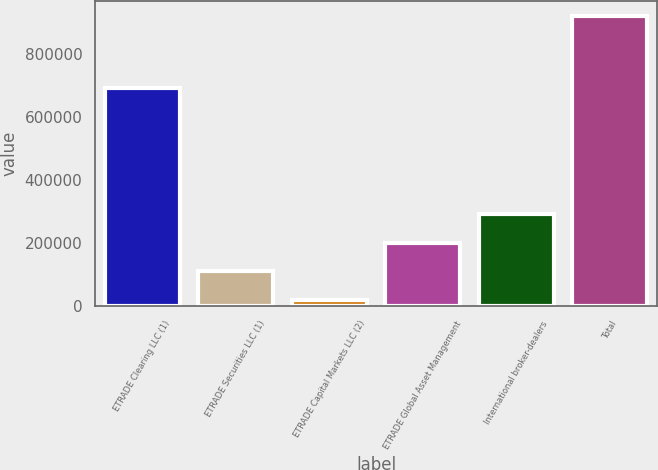<chart> <loc_0><loc_0><loc_500><loc_500><bar_chart><fcel>ETRADE Clearing LLC (1)<fcel>ETRADE Securities LLC (1)<fcel>ETRADE Capital Markets LLC (2)<fcel>ETRADE Global Asset Management<fcel>International broker-dealers<fcel>Total<nl><fcel>690240<fcel>110881<fcel>20944<fcel>200817<fcel>290754<fcel>920310<nl></chart> 